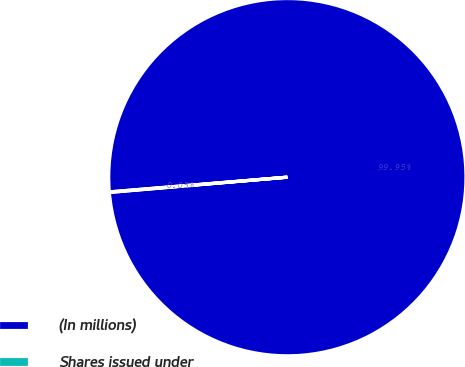<chart> <loc_0><loc_0><loc_500><loc_500><pie_chart><fcel>(In millions)<fcel>Shares issued under<nl><fcel>99.95%<fcel>0.05%<nl></chart> 